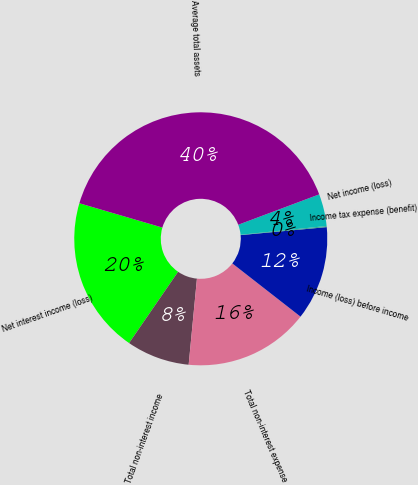Convert chart to OTSL. <chart><loc_0><loc_0><loc_500><loc_500><pie_chart><fcel>Net interest income (loss)<fcel>Total non-interest income<fcel>Total non-interest expense<fcel>Income (loss) before income<fcel>Income tax expense (benefit)<fcel>Net income (loss)<fcel>Average total assets<nl><fcel>19.95%<fcel>8.06%<fcel>15.98%<fcel>12.02%<fcel>0.14%<fcel>4.1%<fcel>39.75%<nl></chart> 